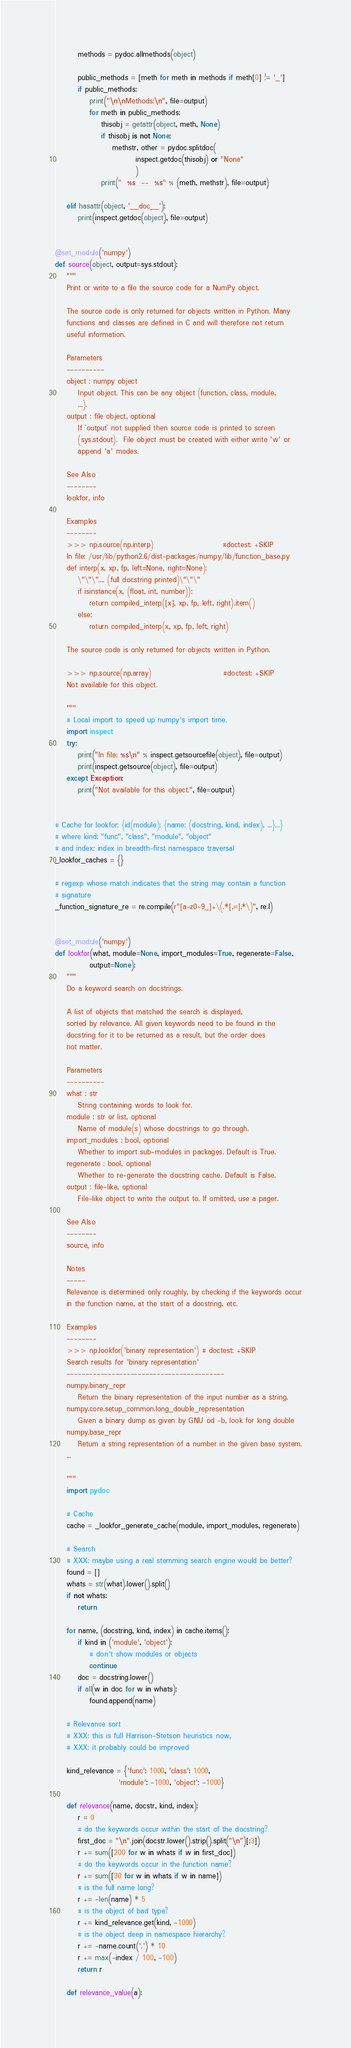<code> <loc_0><loc_0><loc_500><loc_500><_Python_>
        methods = pydoc.allmethods(object)

        public_methods = [meth for meth in methods if meth[0] != '_']
        if public_methods:
            print("\n\nMethods:\n", file=output)
            for meth in public_methods:
                thisobj = getattr(object, meth, None)
                if thisobj is not None:
                    methstr, other = pydoc.splitdoc(
                            inspect.getdoc(thisobj) or "None"
                            )
                print("  %s  --  %s" % (meth, methstr), file=output)

    elif hasattr(object, '__doc__'):
        print(inspect.getdoc(object), file=output)


@set_module('numpy')
def source(object, output=sys.stdout):
    """
    Print or write to a file the source code for a NumPy object.

    The source code is only returned for objects written in Python. Many
    functions and classes are defined in C and will therefore not return
    useful information.

    Parameters
    ----------
    object : numpy object
        Input object. This can be any object (function, class, module,
        ...).
    output : file object, optional
        If `output` not supplied then source code is printed to screen
        (sys.stdout).  File object must be created with either write 'w' or
        append 'a' modes.

    See Also
    --------
    lookfor, info

    Examples
    --------
    >>> np.source(np.interp)                        #doctest: +SKIP
    In file: /usr/lib/python2.6/dist-packages/numpy/lib/function_base.py
    def interp(x, xp, fp, left=None, right=None):
        \"\"\".... (full docstring printed)\"\"\"
        if isinstance(x, (float, int, number)):
            return compiled_interp([x], xp, fp, left, right).item()
        else:
            return compiled_interp(x, xp, fp, left, right)

    The source code is only returned for objects written in Python.

    >>> np.source(np.array)                         #doctest: +SKIP
    Not available for this object.

    """
    # Local import to speed up numpy's import time.
    import inspect
    try:
        print("In file: %s\n" % inspect.getsourcefile(object), file=output)
        print(inspect.getsource(object), file=output)
    except Exception:
        print("Not available for this object.", file=output)


# Cache for lookfor: {id(module): {name: (docstring, kind, index), ...}...}
# where kind: "func", "class", "module", "object"
# and index: index in breadth-first namespace traversal
_lookfor_caches = {}

# regexp whose match indicates that the string may contain a function
# signature
_function_signature_re = re.compile(r"[a-z0-9_]+\(.*[,=].*\)", re.I)


@set_module('numpy')
def lookfor(what, module=None, import_modules=True, regenerate=False,
            output=None):
    """
    Do a keyword search on docstrings.

    A list of objects that matched the search is displayed,
    sorted by relevance. All given keywords need to be found in the
    docstring for it to be returned as a result, but the order does
    not matter.

    Parameters
    ----------
    what : str
        String containing words to look for.
    module : str or list, optional
        Name of module(s) whose docstrings to go through.
    import_modules : bool, optional
        Whether to import sub-modules in packages. Default is True.
    regenerate : bool, optional
        Whether to re-generate the docstring cache. Default is False.
    output : file-like, optional
        File-like object to write the output to. If omitted, use a pager.

    See Also
    --------
    source, info

    Notes
    -----
    Relevance is determined only roughly, by checking if the keywords occur
    in the function name, at the start of a docstring, etc.

    Examples
    --------
    >>> np.lookfor('binary representation') # doctest: +SKIP
    Search results for 'binary representation'
    ------------------------------------------
    numpy.binary_repr
        Return the binary representation of the input number as a string.
    numpy.core.setup_common.long_double_representation
        Given a binary dump as given by GNU od -b, look for long double
    numpy.base_repr
        Return a string representation of a number in the given base system.
    ...

    """
    import pydoc

    # Cache
    cache = _lookfor_generate_cache(module, import_modules, regenerate)

    # Search
    # XXX: maybe using a real stemming search engine would be better?
    found = []
    whats = str(what).lower().split()
    if not whats:
        return

    for name, (docstring, kind, index) in cache.items():
        if kind in ('module', 'object'):
            # don't show modules or objects
            continue
        doc = docstring.lower()
        if all(w in doc for w in whats):
            found.append(name)

    # Relevance sort
    # XXX: this is full Harrison-Stetson heuristics now,
    # XXX: it probably could be improved

    kind_relevance = {'func': 1000, 'class': 1000,
                      'module': -1000, 'object': -1000}

    def relevance(name, docstr, kind, index):
        r = 0
        # do the keywords occur within the start of the docstring?
        first_doc = "\n".join(docstr.lower().strip().split("\n")[:3])
        r += sum([200 for w in whats if w in first_doc])
        # do the keywords occur in the function name?
        r += sum([30 for w in whats if w in name])
        # is the full name long?
        r += -len(name) * 5
        # is the object of bad type?
        r += kind_relevance.get(kind, -1000)
        # is the object deep in namespace hierarchy?
        r += -name.count('.') * 10
        r += max(-index / 100, -100)
        return r

    def relevance_value(a):</code> 